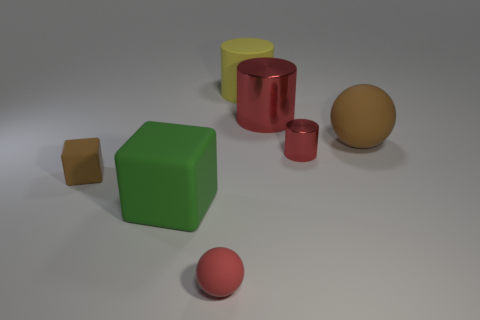There is a rubber block that is the same size as the brown matte sphere; what color is it?
Your response must be concise. Green. What number of brown things are right of the large red metallic object?
Keep it short and to the point. 1. Are there any large brown balls that have the same material as the large brown object?
Your response must be concise. No. What shape is the large object that is the same color as the tiny cylinder?
Provide a short and direct response. Cylinder. What is the color of the small matte object that is in front of the small brown block?
Keep it short and to the point. Red. Is the number of yellow matte objects that are in front of the large brown object the same as the number of brown objects that are in front of the green object?
Your response must be concise. Yes. There is a tiny sphere that is in front of the red metal cylinder that is on the left side of the small cylinder; what is its material?
Make the answer very short. Rubber. How many objects are either tiny cylinders or balls to the left of the large red metal cylinder?
Keep it short and to the point. 2. What is the size of the red sphere that is the same material as the yellow thing?
Offer a very short reply. Small. Is the number of tiny red balls on the right side of the small red metal thing greater than the number of cyan balls?
Offer a very short reply. No. 